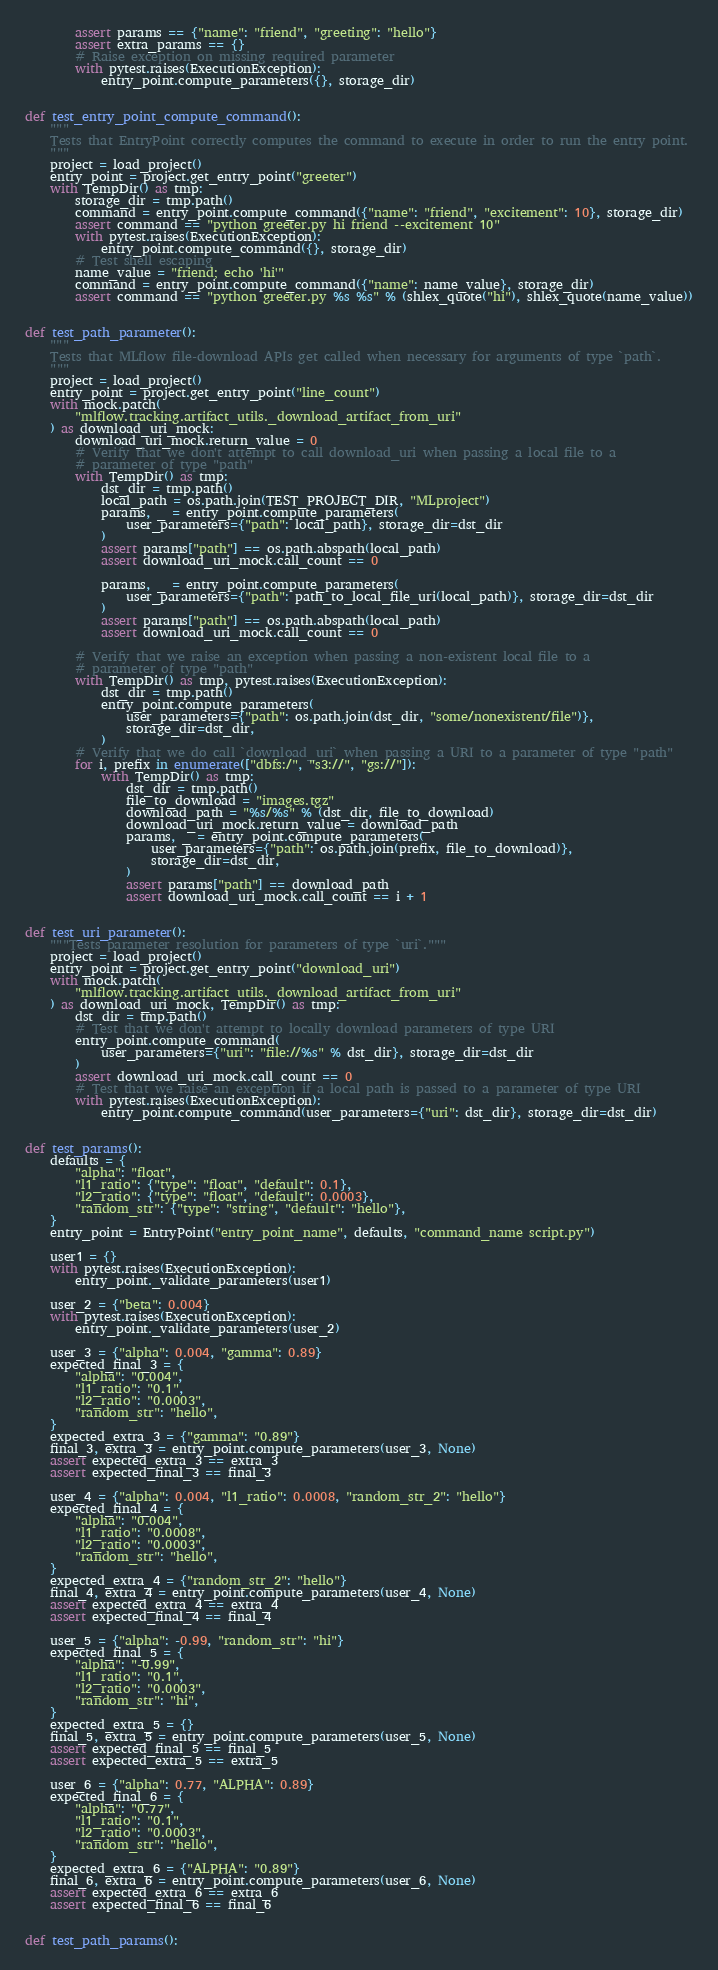Convert code to text. <code><loc_0><loc_0><loc_500><loc_500><_Python_>        assert params == {"name": "friend", "greeting": "hello"}
        assert extra_params == {}
        # Raise exception on missing required parameter
        with pytest.raises(ExecutionException):
            entry_point.compute_parameters({}, storage_dir)


def test_entry_point_compute_command():
    """
    Tests that EntryPoint correctly computes the command to execute in order to run the entry point.
    """
    project = load_project()
    entry_point = project.get_entry_point("greeter")
    with TempDir() as tmp:
        storage_dir = tmp.path()
        command = entry_point.compute_command({"name": "friend", "excitement": 10}, storage_dir)
        assert command == "python greeter.py hi friend --excitement 10"
        with pytest.raises(ExecutionException):
            entry_point.compute_command({}, storage_dir)
        # Test shell escaping
        name_value = "friend; echo 'hi'"
        command = entry_point.compute_command({"name": name_value}, storage_dir)
        assert command == "python greeter.py %s %s" % (shlex_quote("hi"), shlex_quote(name_value))


def test_path_parameter():
    """
    Tests that MLflow file-download APIs get called when necessary for arguments of type `path`.
    """
    project = load_project()
    entry_point = project.get_entry_point("line_count")
    with mock.patch(
        "mlflow.tracking.artifact_utils._download_artifact_from_uri"
    ) as download_uri_mock:
        download_uri_mock.return_value = 0
        # Verify that we don't attempt to call download_uri when passing a local file to a
        # parameter of type "path"
        with TempDir() as tmp:
            dst_dir = tmp.path()
            local_path = os.path.join(TEST_PROJECT_DIR, "MLproject")
            params, _ = entry_point.compute_parameters(
                user_parameters={"path": local_path}, storage_dir=dst_dir
            )
            assert params["path"] == os.path.abspath(local_path)
            assert download_uri_mock.call_count == 0

            params, _ = entry_point.compute_parameters(
                user_parameters={"path": path_to_local_file_uri(local_path)}, storage_dir=dst_dir
            )
            assert params["path"] == os.path.abspath(local_path)
            assert download_uri_mock.call_count == 0

        # Verify that we raise an exception when passing a non-existent local file to a
        # parameter of type "path"
        with TempDir() as tmp, pytest.raises(ExecutionException):
            dst_dir = tmp.path()
            entry_point.compute_parameters(
                user_parameters={"path": os.path.join(dst_dir, "some/nonexistent/file")},
                storage_dir=dst_dir,
            )
        # Verify that we do call `download_uri` when passing a URI to a parameter of type "path"
        for i, prefix in enumerate(["dbfs:/", "s3://", "gs://"]):
            with TempDir() as tmp:
                dst_dir = tmp.path()
                file_to_download = "images.tgz"
                download_path = "%s/%s" % (dst_dir, file_to_download)
                download_uri_mock.return_value = download_path
                params, _ = entry_point.compute_parameters(
                    user_parameters={"path": os.path.join(prefix, file_to_download)},
                    storage_dir=dst_dir,
                )
                assert params["path"] == download_path
                assert download_uri_mock.call_count == i + 1


def test_uri_parameter():
    """Tests parameter resolution for parameters of type `uri`."""
    project = load_project()
    entry_point = project.get_entry_point("download_uri")
    with mock.patch(
        "mlflow.tracking.artifact_utils._download_artifact_from_uri"
    ) as download_uri_mock, TempDir() as tmp:
        dst_dir = tmp.path()
        # Test that we don't attempt to locally download parameters of type URI
        entry_point.compute_command(
            user_parameters={"uri": "file://%s" % dst_dir}, storage_dir=dst_dir
        )
        assert download_uri_mock.call_count == 0
        # Test that we raise an exception if a local path is passed to a parameter of type URI
        with pytest.raises(ExecutionException):
            entry_point.compute_command(user_parameters={"uri": dst_dir}, storage_dir=dst_dir)


def test_params():
    defaults = {
        "alpha": "float",
        "l1_ratio": {"type": "float", "default": 0.1},
        "l2_ratio": {"type": "float", "default": 0.0003},
        "random_str": {"type": "string", "default": "hello"},
    }
    entry_point = EntryPoint("entry_point_name", defaults, "command_name script.py")

    user1 = {}
    with pytest.raises(ExecutionException):
        entry_point._validate_parameters(user1)

    user_2 = {"beta": 0.004}
    with pytest.raises(ExecutionException):
        entry_point._validate_parameters(user_2)

    user_3 = {"alpha": 0.004, "gamma": 0.89}
    expected_final_3 = {
        "alpha": "0.004",
        "l1_ratio": "0.1",
        "l2_ratio": "0.0003",
        "random_str": "hello",
    }
    expected_extra_3 = {"gamma": "0.89"}
    final_3, extra_3 = entry_point.compute_parameters(user_3, None)
    assert expected_extra_3 == extra_3
    assert expected_final_3 == final_3

    user_4 = {"alpha": 0.004, "l1_ratio": 0.0008, "random_str_2": "hello"}
    expected_final_4 = {
        "alpha": "0.004",
        "l1_ratio": "0.0008",
        "l2_ratio": "0.0003",
        "random_str": "hello",
    }
    expected_extra_4 = {"random_str_2": "hello"}
    final_4, extra_4 = entry_point.compute_parameters(user_4, None)
    assert expected_extra_4 == extra_4
    assert expected_final_4 == final_4

    user_5 = {"alpha": -0.99, "random_str": "hi"}
    expected_final_5 = {
        "alpha": "-0.99",
        "l1_ratio": "0.1",
        "l2_ratio": "0.0003",
        "random_str": "hi",
    }
    expected_extra_5 = {}
    final_5, extra_5 = entry_point.compute_parameters(user_5, None)
    assert expected_final_5 == final_5
    assert expected_extra_5 == extra_5

    user_6 = {"alpha": 0.77, "ALPHA": 0.89}
    expected_final_6 = {
        "alpha": "0.77",
        "l1_ratio": "0.1",
        "l2_ratio": "0.0003",
        "random_str": "hello",
    }
    expected_extra_6 = {"ALPHA": "0.89"}
    final_6, extra_6 = entry_point.compute_parameters(user_6, None)
    assert expected_extra_6 == extra_6
    assert expected_final_6 == final_6


def test_path_params():</code> 